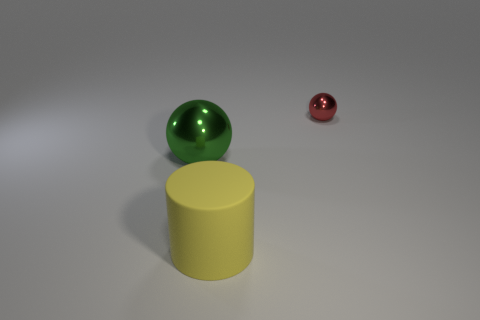There is a green object; does it have the same shape as the big object that is to the right of the large green shiny sphere?
Your answer should be very brief. No. What number of metal things are either big green spheres or small red balls?
Offer a very short reply. 2. Are there any other metallic things that have the same color as the small object?
Provide a short and direct response. No. Are any tiny red metallic things visible?
Ensure brevity in your answer.  Yes. Does the big yellow object have the same shape as the tiny red thing?
Provide a succinct answer. No. How many small objects are green objects or rubber cylinders?
Keep it short and to the point. 0. The large sphere has what color?
Ensure brevity in your answer.  Green. The object that is in front of the metallic thing that is to the left of the small red shiny ball is what shape?
Ensure brevity in your answer.  Cylinder. Are there any small brown cubes that have the same material as the cylinder?
Your response must be concise. No. There is a metallic thing that is to the left of the yellow object; is its size the same as the small red thing?
Offer a very short reply. No. 